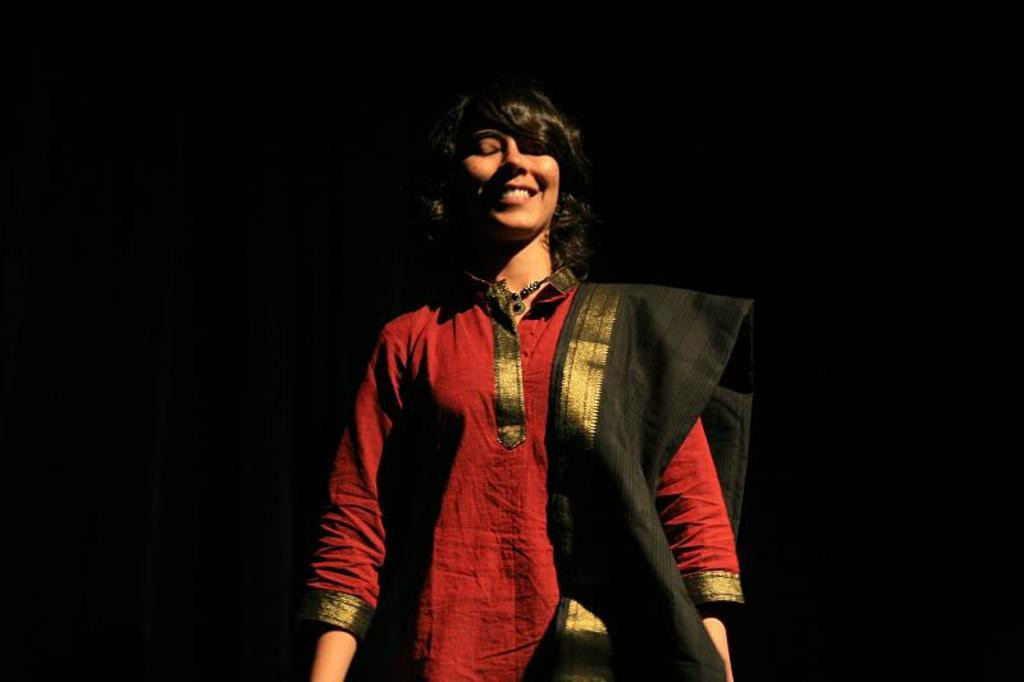Who is present in the image? There is a woman in the image. What is the woman doing in the image? The woman is standing in the image. What is the woman's facial expression in the image? The woman is smiling in the image. What color is the background of the image? The background of the image is black. What type of advertisement can be seen in the background of the image? There is no advertisement present in the image; the background is black. What color crayon is the woman holding in the image? There is no crayon present in the image; the woman is not holding any object. 